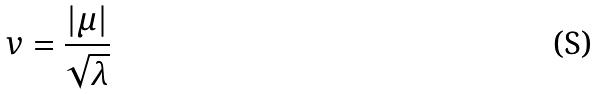<formula> <loc_0><loc_0><loc_500><loc_500>v = \frac { | \mu | } { \sqrt { \lambda } }</formula> 